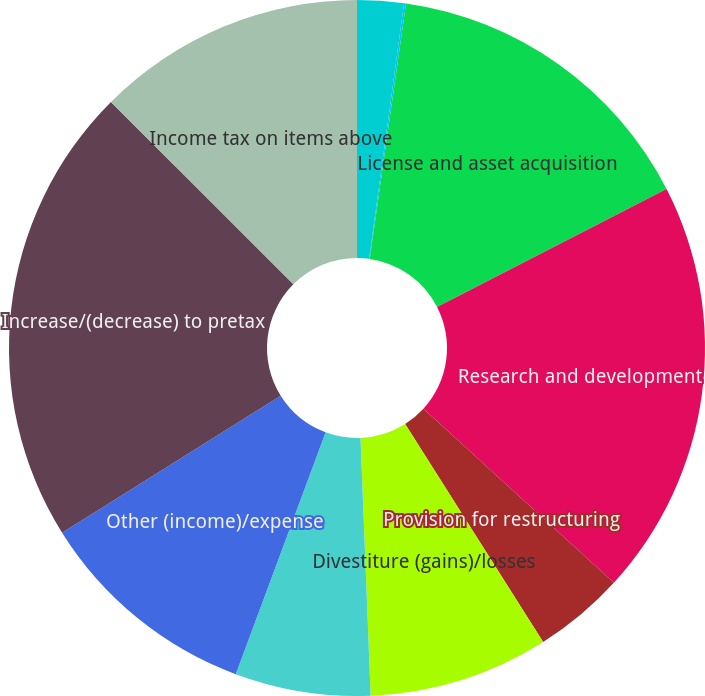Convert chart. <chart><loc_0><loc_0><loc_500><loc_500><pie_chart><fcel>Cost of products sold (a)<fcel>Marketing selling and<fcel>License and asset acquisition<fcel>Research and development<fcel>Provision for restructuring<fcel>Divestiture (gains)/losses<fcel>Pension charges<fcel>Other (income)/expense<fcel>Increase/(decrease) to pretax<fcel>Income tax on items above<nl><fcel>2.16%<fcel>0.09%<fcel>15.2%<fcel>19.34%<fcel>4.23%<fcel>8.36%<fcel>6.29%<fcel>10.43%<fcel>21.41%<fcel>12.5%<nl></chart> 